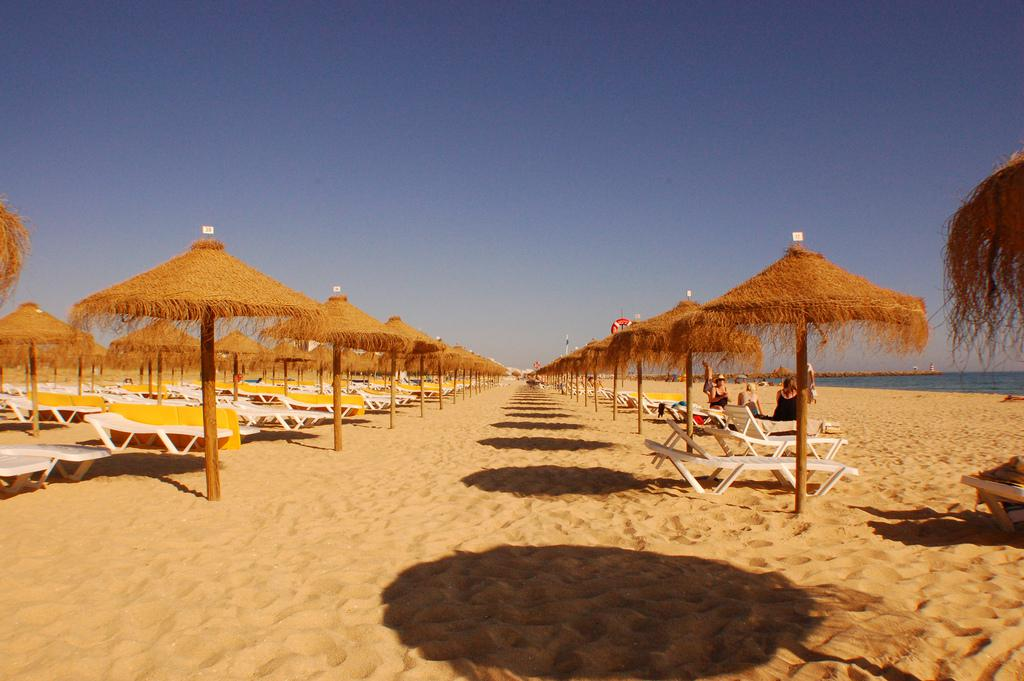Question: how is the scene?
Choices:
A. Dark and gloomy.
B. Bright daytime.
C. Cheerful and calm.
D. Chaotic.
Answer with the letter. Answer: B Question: what is sitting next to lounge chairs?
Choices:
A. Margaritas.
B. Fruit trays.
C. Many large straw umbrellas.
D. Beach towels.
Answer with the letter. Answer: C Question: how is the sky colour?
Choices:
A. Bright blue.
B. Deep blue, almost purple.
C. Grey.
D. Pretty violet and cloudless.
Answer with the letter. Answer: D Question: what are on the sand?
Choices:
A. Seashells.
B. Towels.
C. Flip flops.
D. Shadows.
Answer with the letter. Answer: D Question: where are the people?
Choices:
A. Park.
B. Pool.
C. Beach.
D. Golf course.
Answer with the letter. Answer: C Question: what do the umbrellas do?
Choices:
A. Sit in the cocktail glasses.
B. Protect from the rain.
C. Serve as a stylish accessory.
D. Provide shade.
Answer with the letter. Answer: D Question: how will they be protected from the sun?
Choices:
A. The umbrellas.
B. The cabana.
C. Suntan lotion.
D. A big, floppy hat.
Answer with the letter. Answer: A Question: why are there yellow barriers?
Choices:
A. To divide the beach chairs.
B. To mark the construction site.
C. To give privacy.
D. To show the road ends.
Answer with the letter. Answer: A Question: who is near the water?
Choices:
A. A boat.
B. A small group of people.
C. The car.
D. A man.
Answer with the letter. Answer: B Question: how is the weather?
Choices:
A. Cold.
B. Windy.
C. Hot.
D. Warm and sunny.
Answer with the letter. Answer: D Question: what is the beach filled with?
Choices:
A. Sand.
B. Lounge chairs and straw umbrellas.
C. Water.
D. People.
Answer with the letter. Answer: B Question: what colors are the chairs?
Choices:
A. Some are yellow, others are white.
B. Some are green, others are blue.
C. Some are black, others are brown.
D. Some are red, others are grey.
Answer with the letter. Answer: A Question: how are the chairs set up?
Choices:
A. The chairs a stacked.
B. In a circle.
C. In rows.
D. Back to back.
Answer with the letter. Answer: C Question: what shape shadows are being made by the umbrellas?
Choices:
A. Square.
B. Rectangular.
C. Circular.
D. Octagon.
Answer with the letter. Answer: C Question: what is on the sand?
Choices:
A. Seagulls.
B. Shadows.
C. Trash.
D. Crabs.
Answer with the letter. Answer: B Question: what is in the background?
Choices:
A. A pier.
B. Beach goers.
C. Surfers in the water.
D. The sunset.
Answer with the letter. Answer: A Question: how does the sky look?
Choices:
A. Clear.
B. There is lightning.
C. It is dark.
D. It is sunny and raining at the same time.
Answer with the letter. Answer: A 